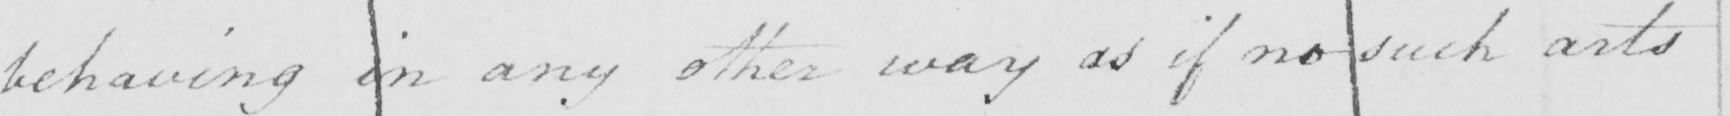What does this handwritten line say? behaving in any other way as if no such arts 